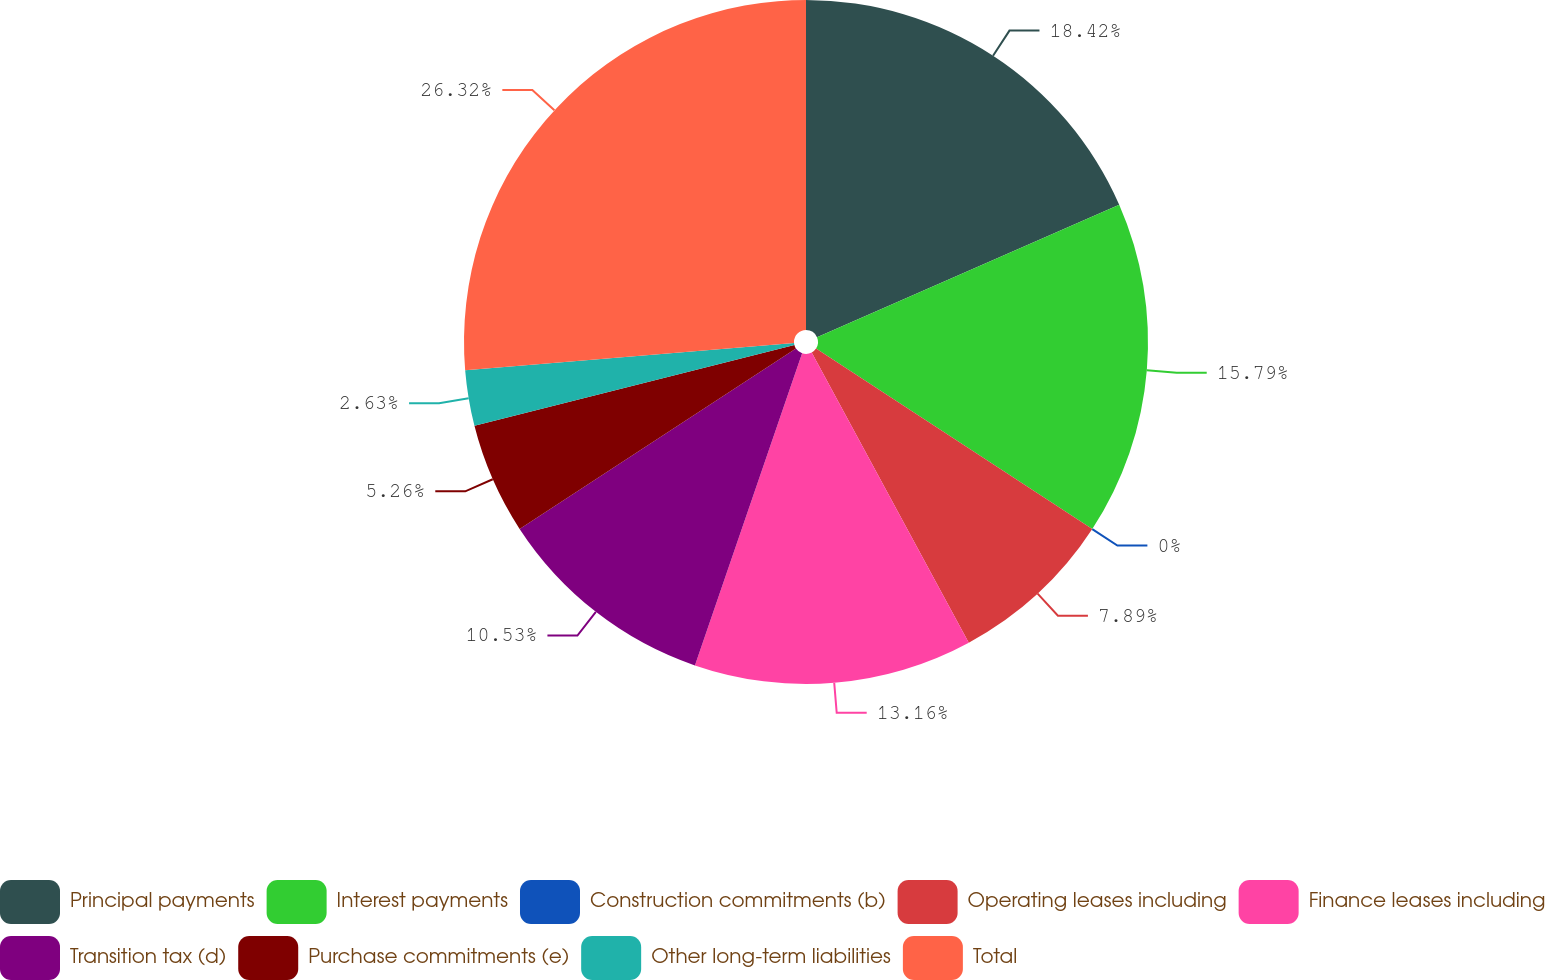Convert chart. <chart><loc_0><loc_0><loc_500><loc_500><pie_chart><fcel>Principal payments<fcel>Interest payments<fcel>Construction commitments (b)<fcel>Operating leases including<fcel>Finance leases including<fcel>Transition tax (d)<fcel>Purchase commitments (e)<fcel>Other long-term liabilities<fcel>Total<nl><fcel>18.42%<fcel>15.79%<fcel>0.0%<fcel>7.89%<fcel>13.16%<fcel>10.53%<fcel>5.26%<fcel>2.63%<fcel>26.31%<nl></chart> 